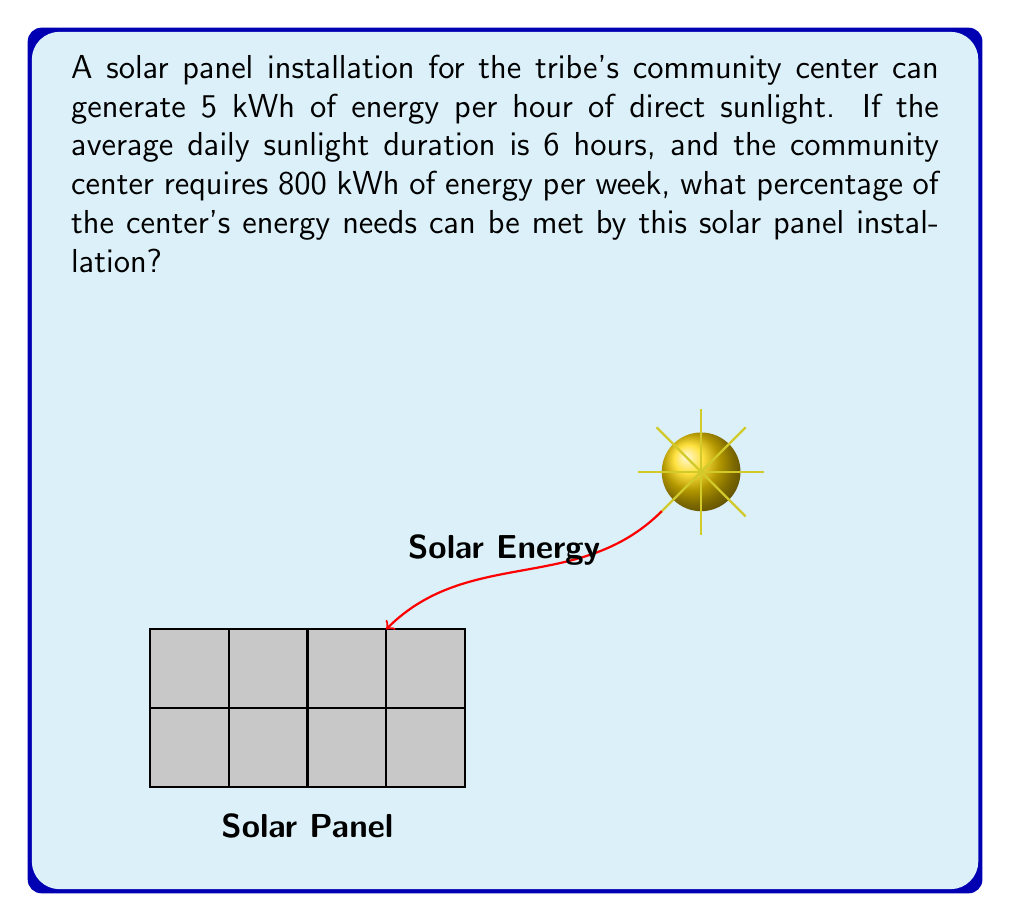Can you solve this math problem? Let's approach this step-by-step:

1) First, calculate the daily energy generation:
   $$\text{Daily Energy} = 5 \text{ kWh/hour} \times 6 \text{ hours} = 30 \text{ kWh/day}$$

2) Now, calculate the weekly energy generation:
   $$\text{Weekly Energy} = 30 \text{ kWh/day} \times 7 \text{ days} = 210 \text{ kWh/week}$$

3) The community center requires 800 kWh per week. To find the percentage of needs met, we use:
   $$\text{Percentage} = \frac{\text{Energy Generated}}{\text{Energy Required}} \times 100\%$$

4) Plugging in our values:
   $$\text{Percentage} = \frac{210 \text{ kWh/week}}{800 \text{ kWh/week}} \times 100\%$$

5) Simplify:
   $$\text{Percentage} = 0.2625 \times 100\% = 26.25\%$$

Therefore, the solar panel installation can meet 26.25% of the community center's energy needs.
Answer: 26.25% 